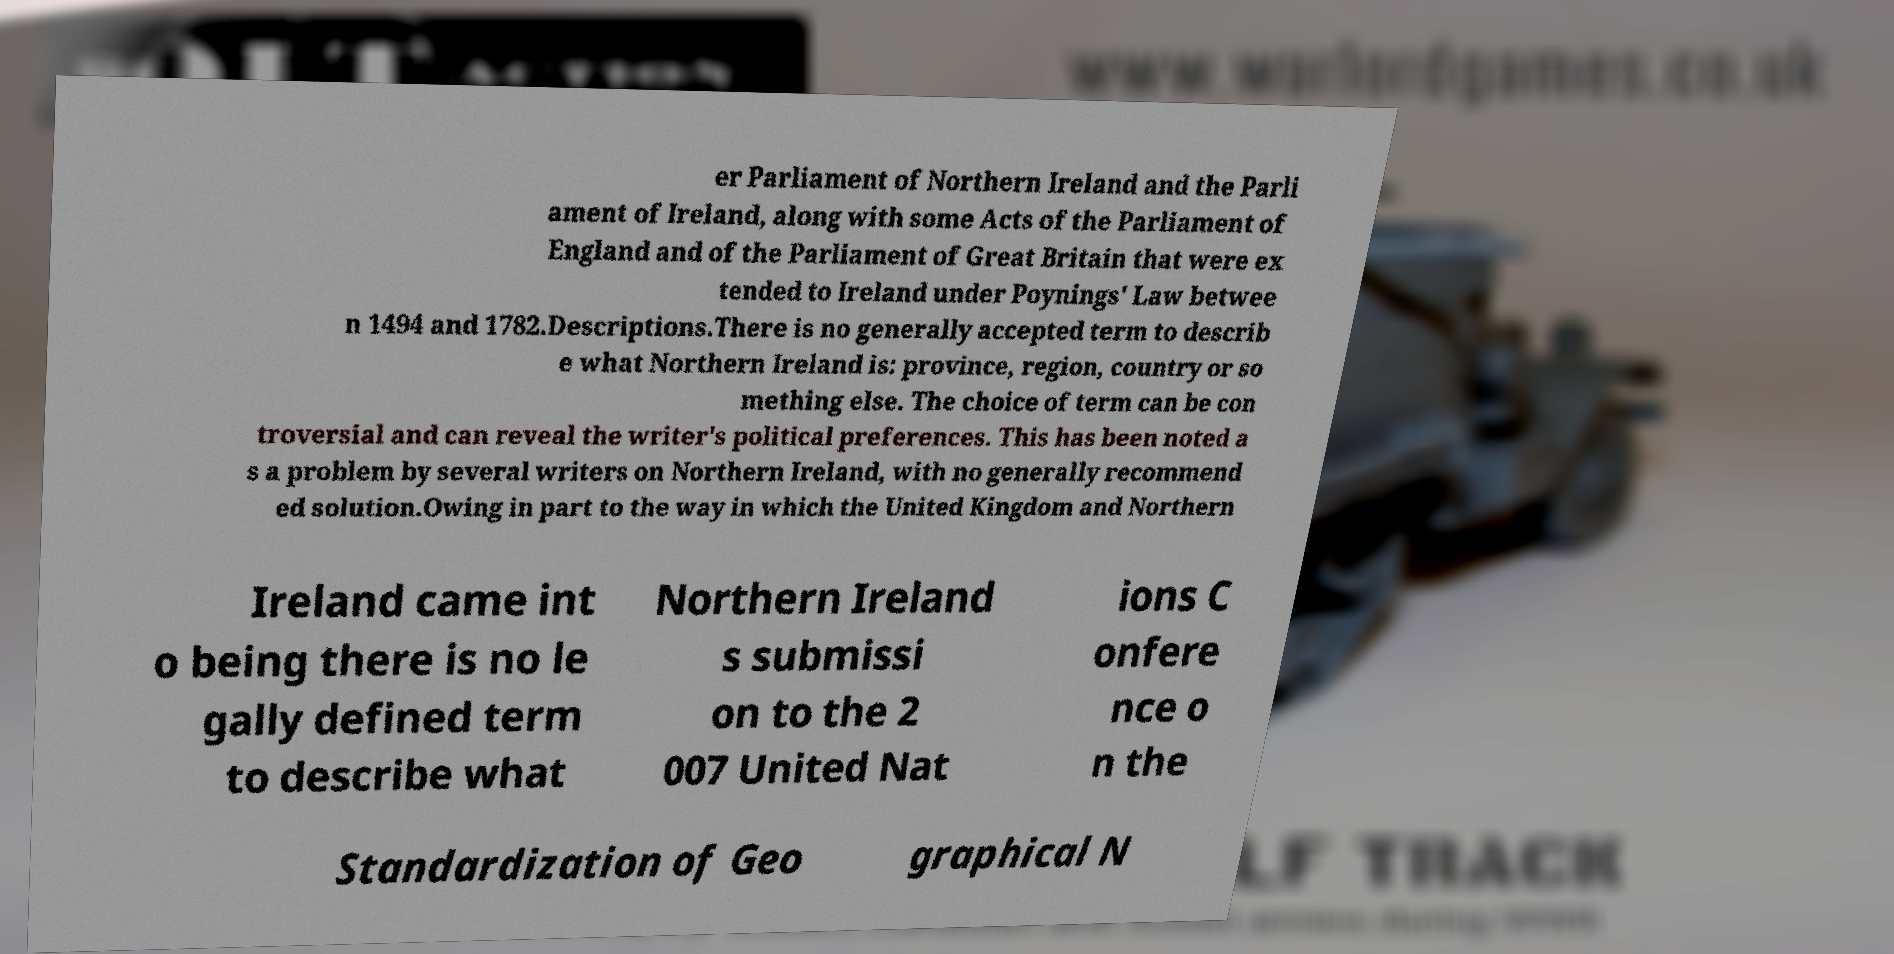Please read and relay the text visible in this image. What does it say? er Parliament of Northern Ireland and the Parli ament of Ireland, along with some Acts of the Parliament of England and of the Parliament of Great Britain that were ex tended to Ireland under Poynings' Law betwee n 1494 and 1782.Descriptions.There is no generally accepted term to describ e what Northern Ireland is: province, region, country or so mething else. The choice of term can be con troversial and can reveal the writer's political preferences. This has been noted a s a problem by several writers on Northern Ireland, with no generally recommend ed solution.Owing in part to the way in which the United Kingdom and Northern Ireland came int o being there is no le gally defined term to describe what Northern Ireland s submissi on to the 2 007 United Nat ions C onfere nce o n the Standardization of Geo graphical N 